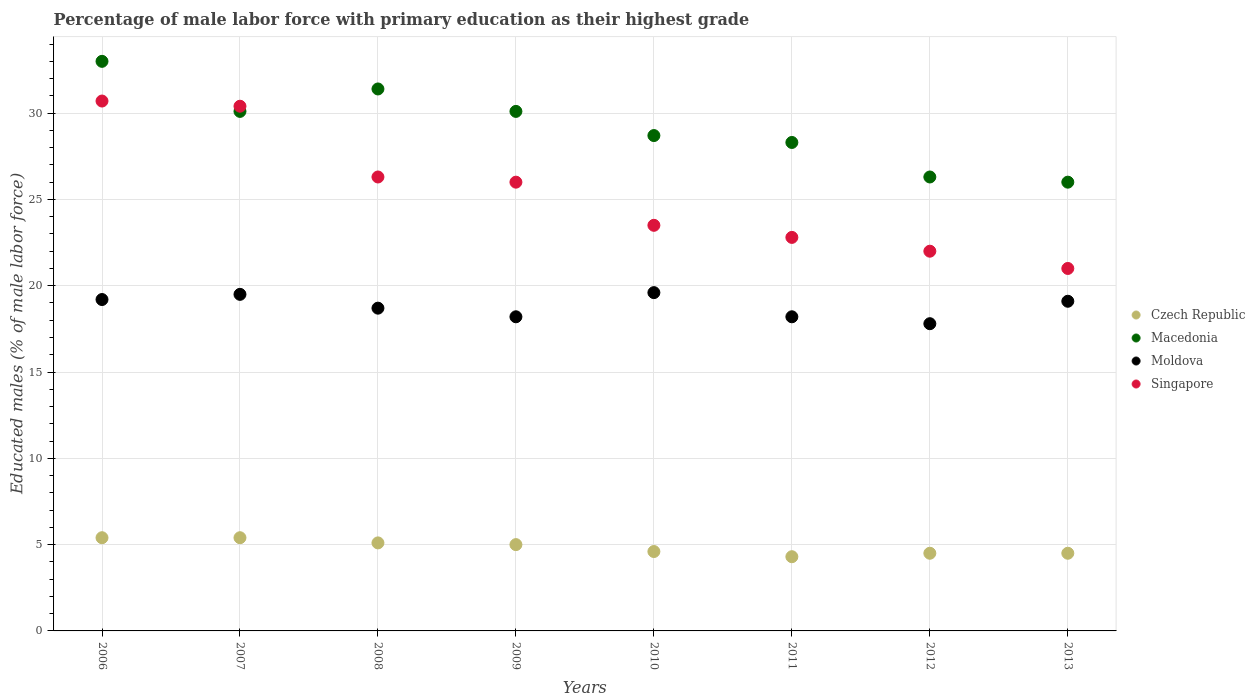Is the number of dotlines equal to the number of legend labels?
Ensure brevity in your answer.  Yes. Across all years, what is the maximum percentage of male labor force with primary education in Singapore?
Provide a succinct answer. 30.7. In which year was the percentage of male labor force with primary education in Singapore maximum?
Your answer should be compact. 2006. What is the total percentage of male labor force with primary education in Singapore in the graph?
Offer a terse response. 202.7. What is the difference between the percentage of male labor force with primary education in Macedonia in 2009 and that in 2013?
Provide a succinct answer. 4.1. What is the difference between the percentage of male labor force with primary education in Macedonia in 2013 and the percentage of male labor force with primary education in Singapore in 2009?
Make the answer very short. 0. What is the average percentage of male labor force with primary education in Singapore per year?
Provide a short and direct response. 25.34. In the year 2007, what is the difference between the percentage of male labor force with primary education in Moldova and percentage of male labor force with primary education in Singapore?
Provide a succinct answer. -10.9. In how many years, is the percentage of male labor force with primary education in Czech Republic greater than 21 %?
Keep it short and to the point. 0. What is the ratio of the percentage of male labor force with primary education in Czech Republic in 2006 to that in 2010?
Your response must be concise. 1.17. Is the percentage of male labor force with primary education in Moldova in 2011 less than that in 2013?
Offer a very short reply. Yes. What is the difference between the highest and the second highest percentage of male labor force with primary education in Singapore?
Give a very brief answer. 0.3. What is the difference between the highest and the lowest percentage of male labor force with primary education in Singapore?
Offer a terse response. 9.7. In how many years, is the percentage of male labor force with primary education in Czech Republic greater than the average percentage of male labor force with primary education in Czech Republic taken over all years?
Offer a very short reply. 4. Does the percentage of male labor force with primary education in Singapore monotonically increase over the years?
Your answer should be very brief. No. Is the percentage of male labor force with primary education in Macedonia strictly less than the percentage of male labor force with primary education in Czech Republic over the years?
Make the answer very short. No. How many years are there in the graph?
Offer a very short reply. 8. What is the difference between two consecutive major ticks on the Y-axis?
Give a very brief answer. 5. Are the values on the major ticks of Y-axis written in scientific E-notation?
Keep it short and to the point. No. What is the title of the graph?
Offer a terse response. Percentage of male labor force with primary education as their highest grade. Does "Mexico" appear as one of the legend labels in the graph?
Offer a terse response. No. What is the label or title of the Y-axis?
Offer a terse response. Educated males (% of male labor force). What is the Educated males (% of male labor force) of Czech Republic in 2006?
Give a very brief answer. 5.4. What is the Educated males (% of male labor force) of Moldova in 2006?
Ensure brevity in your answer.  19.2. What is the Educated males (% of male labor force) in Singapore in 2006?
Make the answer very short. 30.7. What is the Educated males (% of male labor force) of Czech Republic in 2007?
Offer a very short reply. 5.4. What is the Educated males (% of male labor force) in Macedonia in 2007?
Provide a short and direct response. 30.1. What is the Educated males (% of male labor force) in Moldova in 2007?
Offer a very short reply. 19.5. What is the Educated males (% of male labor force) of Singapore in 2007?
Keep it short and to the point. 30.4. What is the Educated males (% of male labor force) of Czech Republic in 2008?
Keep it short and to the point. 5.1. What is the Educated males (% of male labor force) of Macedonia in 2008?
Offer a terse response. 31.4. What is the Educated males (% of male labor force) in Moldova in 2008?
Offer a terse response. 18.7. What is the Educated males (% of male labor force) in Singapore in 2008?
Ensure brevity in your answer.  26.3. What is the Educated males (% of male labor force) in Macedonia in 2009?
Offer a terse response. 30.1. What is the Educated males (% of male labor force) in Moldova in 2009?
Give a very brief answer. 18.2. What is the Educated males (% of male labor force) of Singapore in 2009?
Give a very brief answer. 26. What is the Educated males (% of male labor force) of Czech Republic in 2010?
Keep it short and to the point. 4.6. What is the Educated males (% of male labor force) in Macedonia in 2010?
Your answer should be compact. 28.7. What is the Educated males (% of male labor force) of Moldova in 2010?
Make the answer very short. 19.6. What is the Educated males (% of male labor force) in Czech Republic in 2011?
Offer a terse response. 4.3. What is the Educated males (% of male labor force) in Macedonia in 2011?
Your response must be concise. 28.3. What is the Educated males (% of male labor force) in Moldova in 2011?
Your response must be concise. 18.2. What is the Educated males (% of male labor force) in Singapore in 2011?
Your answer should be very brief. 22.8. What is the Educated males (% of male labor force) of Czech Republic in 2012?
Ensure brevity in your answer.  4.5. What is the Educated males (% of male labor force) in Macedonia in 2012?
Give a very brief answer. 26.3. What is the Educated males (% of male labor force) in Moldova in 2012?
Ensure brevity in your answer.  17.8. What is the Educated males (% of male labor force) of Moldova in 2013?
Provide a succinct answer. 19.1. What is the Educated males (% of male labor force) in Singapore in 2013?
Keep it short and to the point. 21. Across all years, what is the maximum Educated males (% of male labor force) of Czech Republic?
Offer a very short reply. 5.4. Across all years, what is the maximum Educated males (% of male labor force) in Macedonia?
Your response must be concise. 33. Across all years, what is the maximum Educated males (% of male labor force) of Moldova?
Give a very brief answer. 19.6. Across all years, what is the maximum Educated males (% of male labor force) in Singapore?
Provide a short and direct response. 30.7. Across all years, what is the minimum Educated males (% of male labor force) in Czech Republic?
Give a very brief answer. 4.3. Across all years, what is the minimum Educated males (% of male labor force) in Macedonia?
Keep it short and to the point. 26. Across all years, what is the minimum Educated males (% of male labor force) of Moldova?
Make the answer very short. 17.8. Across all years, what is the minimum Educated males (% of male labor force) of Singapore?
Provide a short and direct response. 21. What is the total Educated males (% of male labor force) of Czech Republic in the graph?
Keep it short and to the point. 38.8. What is the total Educated males (% of male labor force) of Macedonia in the graph?
Provide a succinct answer. 233.9. What is the total Educated males (% of male labor force) of Moldova in the graph?
Your answer should be compact. 150.3. What is the total Educated males (% of male labor force) in Singapore in the graph?
Keep it short and to the point. 202.7. What is the difference between the Educated males (% of male labor force) in Macedonia in 2006 and that in 2008?
Provide a succinct answer. 1.6. What is the difference between the Educated males (% of male labor force) in Czech Republic in 2006 and that in 2009?
Give a very brief answer. 0.4. What is the difference between the Educated males (% of male labor force) in Macedonia in 2006 and that in 2009?
Provide a succinct answer. 2.9. What is the difference between the Educated males (% of male labor force) in Czech Republic in 2006 and that in 2010?
Your answer should be compact. 0.8. What is the difference between the Educated males (% of male labor force) of Moldova in 2006 and that in 2010?
Your answer should be compact. -0.4. What is the difference between the Educated males (% of male labor force) in Czech Republic in 2006 and that in 2011?
Your answer should be compact. 1.1. What is the difference between the Educated males (% of male labor force) in Macedonia in 2006 and that in 2011?
Give a very brief answer. 4.7. What is the difference between the Educated males (% of male labor force) in Moldova in 2006 and that in 2011?
Provide a succinct answer. 1. What is the difference between the Educated males (% of male labor force) in Singapore in 2006 and that in 2011?
Your response must be concise. 7.9. What is the difference between the Educated males (% of male labor force) in Czech Republic in 2006 and that in 2012?
Ensure brevity in your answer.  0.9. What is the difference between the Educated males (% of male labor force) of Macedonia in 2006 and that in 2012?
Make the answer very short. 6.7. What is the difference between the Educated males (% of male labor force) in Macedonia in 2007 and that in 2008?
Your response must be concise. -1.3. What is the difference between the Educated males (% of male labor force) in Moldova in 2007 and that in 2008?
Offer a very short reply. 0.8. What is the difference between the Educated males (% of male labor force) of Moldova in 2007 and that in 2009?
Provide a short and direct response. 1.3. What is the difference between the Educated males (% of male labor force) in Czech Republic in 2007 and that in 2010?
Offer a very short reply. 0.8. What is the difference between the Educated males (% of male labor force) of Moldova in 2007 and that in 2010?
Make the answer very short. -0.1. What is the difference between the Educated males (% of male labor force) in Macedonia in 2007 and that in 2011?
Offer a terse response. 1.8. What is the difference between the Educated males (% of male labor force) in Moldova in 2007 and that in 2011?
Provide a short and direct response. 1.3. What is the difference between the Educated males (% of male labor force) in Macedonia in 2007 and that in 2012?
Provide a succinct answer. 3.8. What is the difference between the Educated males (% of male labor force) of Macedonia in 2007 and that in 2013?
Provide a short and direct response. 4.1. What is the difference between the Educated males (% of male labor force) of Moldova in 2007 and that in 2013?
Your answer should be compact. 0.4. What is the difference between the Educated males (% of male labor force) of Singapore in 2007 and that in 2013?
Provide a short and direct response. 9.4. What is the difference between the Educated males (% of male labor force) of Macedonia in 2008 and that in 2009?
Your answer should be very brief. 1.3. What is the difference between the Educated males (% of male labor force) of Macedonia in 2008 and that in 2010?
Provide a succinct answer. 2.7. What is the difference between the Educated males (% of male labor force) of Czech Republic in 2008 and that in 2011?
Provide a succinct answer. 0.8. What is the difference between the Educated males (% of male labor force) of Macedonia in 2008 and that in 2011?
Provide a short and direct response. 3.1. What is the difference between the Educated males (% of male labor force) in Czech Republic in 2008 and that in 2013?
Give a very brief answer. 0.6. What is the difference between the Educated males (% of male labor force) in Moldova in 2008 and that in 2013?
Ensure brevity in your answer.  -0.4. What is the difference between the Educated males (% of male labor force) of Singapore in 2008 and that in 2013?
Provide a succinct answer. 5.3. What is the difference between the Educated males (% of male labor force) in Czech Republic in 2009 and that in 2010?
Keep it short and to the point. 0.4. What is the difference between the Educated males (% of male labor force) in Macedonia in 2009 and that in 2010?
Offer a terse response. 1.4. What is the difference between the Educated males (% of male labor force) in Czech Republic in 2009 and that in 2011?
Provide a short and direct response. 0.7. What is the difference between the Educated males (% of male labor force) in Macedonia in 2009 and that in 2012?
Offer a very short reply. 3.8. What is the difference between the Educated males (% of male labor force) of Macedonia in 2009 and that in 2013?
Give a very brief answer. 4.1. What is the difference between the Educated males (% of male labor force) in Moldova in 2009 and that in 2013?
Provide a succinct answer. -0.9. What is the difference between the Educated males (% of male labor force) in Singapore in 2009 and that in 2013?
Offer a very short reply. 5. What is the difference between the Educated males (% of male labor force) of Macedonia in 2010 and that in 2012?
Make the answer very short. 2.4. What is the difference between the Educated males (% of male labor force) in Czech Republic in 2010 and that in 2013?
Your answer should be compact. 0.1. What is the difference between the Educated males (% of male labor force) in Macedonia in 2010 and that in 2013?
Give a very brief answer. 2.7. What is the difference between the Educated males (% of male labor force) of Moldova in 2011 and that in 2012?
Offer a very short reply. 0.4. What is the difference between the Educated males (% of male labor force) of Singapore in 2011 and that in 2012?
Make the answer very short. 0.8. What is the difference between the Educated males (% of male labor force) of Czech Republic in 2011 and that in 2013?
Provide a short and direct response. -0.2. What is the difference between the Educated males (% of male labor force) of Macedonia in 2011 and that in 2013?
Offer a terse response. 2.3. What is the difference between the Educated males (% of male labor force) of Singapore in 2011 and that in 2013?
Your answer should be very brief. 1.8. What is the difference between the Educated males (% of male labor force) in Czech Republic in 2012 and that in 2013?
Offer a terse response. 0. What is the difference between the Educated males (% of male labor force) in Singapore in 2012 and that in 2013?
Make the answer very short. 1. What is the difference between the Educated males (% of male labor force) in Czech Republic in 2006 and the Educated males (% of male labor force) in Macedonia in 2007?
Make the answer very short. -24.7. What is the difference between the Educated males (% of male labor force) of Czech Republic in 2006 and the Educated males (% of male labor force) of Moldova in 2007?
Keep it short and to the point. -14.1. What is the difference between the Educated males (% of male labor force) of Macedonia in 2006 and the Educated males (% of male labor force) of Singapore in 2007?
Your answer should be very brief. 2.6. What is the difference between the Educated males (% of male labor force) in Moldova in 2006 and the Educated males (% of male labor force) in Singapore in 2007?
Offer a very short reply. -11.2. What is the difference between the Educated males (% of male labor force) of Czech Republic in 2006 and the Educated males (% of male labor force) of Moldova in 2008?
Your answer should be compact. -13.3. What is the difference between the Educated males (% of male labor force) in Czech Republic in 2006 and the Educated males (% of male labor force) in Singapore in 2008?
Give a very brief answer. -20.9. What is the difference between the Educated males (% of male labor force) of Macedonia in 2006 and the Educated males (% of male labor force) of Moldova in 2008?
Offer a very short reply. 14.3. What is the difference between the Educated males (% of male labor force) of Macedonia in 2006 and the Educated males (% of male labor force) of Singapore in 2008?
Offer a very short reply. 6.7. What is the difference between the Educated males (% of male labor force) of Moldova in 2006 and the Educated males (% of male labor force) of Singapore in 2008?
Ensure brevity in your answer.  -7.1. What is the difference between the Educated males (% of male labor force) of Czech Republic in 2006 and the Educated males (% of male labor force) of Macedonia in 2009?
Make the answer very short. -24.7. What is the difference between the Educated males (% of male labor force) in Czech Republic in 2006 and the Educated males (% of male labor force) in Moldova in 2009?
Provide a succinct answer. -12.8. What is the difference between the Educated males (% of male labor force) in Czech Republic in 2006 and the Educated males (% of male labor force) in Singapore in 2009?
Offer a very short reply. -20.6. What is the difference between the Educated males (% of male labor force) in Macedonia in 2006 and the Educated males (% of male labor force) in Moldova in 2009?
Your answer should be compact. 14.8. What is the difference between the Educated males (% of male labor force) in Macedonia in 2006 and the Educated males (% of male labor force) in Singapore in 2009?
Provide a short and direct response. 7. What is the difference between the Educated males (% of male labor force) in Czech Republic in 2006 and the Educated males (% of male labor force) in Macedonia in 2010?
Provide a short and direct response. -23.3. What is the difference between the Educated males (% of male labor force) of Czech Republic in 2006 and the Educated males (% of male labor force) of Moldova in 2010?
Provide a succinct answer. -14.2. What is the difference between the Educated males (% of male labor force) in Czech Republic in 2006 and the Educated males (% of male labor force) in Singapore in 2010?
Keep it short and to the point. -18.1. What is the difference between the Educated males (% of male labor force) in Czech Republic in 2006 and the Educated males (% of male labor force) in Macedonia in 2011?
Provide a succinct answer. -22.9. What is the difference between the Educated males (% of male labor force) in Czech Republic in 2006 and the Educated males (% of male labor force) in Singapore in 2011?
Your answer should be compact. -17.4. What is the difference between the Educated males (% of male labor force) in Czech Republic in 2006 and the Educated males (% of male labor force) in Macedonia in 2012?
Make the answer very short. -20.9. What is the difference between the Educated males (% of male labor force) in Czech Republic in 2006 and the Educated males (% of male labor force) in Singapore in 2012?
Offer a very short reply. -16.6. What is the difference between the Educated males (% of male labor force) in Macedonia in 2006 and the Educated males (% of male labor force) in Moldova in 2012?
Make the answer very short. 15.2. What is the difference between the Educated males (% of male labor force) of Macedonia in 2006 and the Educated males (% of male labor force) of Singapore in 2012?
Ensure brevity in your answer.  11. What is the difference between the Educated males (% of male labor force) of Czech Republic in 2006 and the Educated males (% of male labor force) of Macedonia in 2013?
Ensure brevity in your answer.  -20.6. What is the difference between the Educated males (% of male labor force) in Czech Republic in 2006 and the Educated males (% of male labor force) in Moldova in 2013?
Offer a very short reply. -13.7. What is the difference between the Educated males (% of male labor force) of Czech Republic in 2006 and the Educated males (% of male labor force) of Singapore in 2013?
Offer a very short reply. -15.6. What is the difference between the Educated males (% of male labor force) of Macedonia in 2006 and the Educated males (% of male labor force) of Moldova in 2013?
Ensure brevity in your answer.  13.9. What is the difference between the Educated males (% of male labor force) of Macedonia in 2006 and the Educated males (% of male labor force) of Singapore in 2013?
Your answer should be very brief. 12. What is the difference between the Educated males (% of male labor force) in Czech Republic in 2007 and the Educated males (% of male labor force) in Singapore in 2008?
Your response must be concise. -20.9. What is the difference between the Educated males (% of male labor force) of Czech Republic in 2007 and the Educated males (% of male labor force) of Macedonia in 2009?
Make the answer very short. -24.7. What is the difference between the Educated males (% of male labor force) of Czech Republic in 2007 and the Educated males (% of male labor force) of Moldova in 2009?
Provide a succinct answer. -12.8. What is the difference between the Educated males (% of male labor force) in Czech Republic in 2007 and the Educated males (% of male labor force) in Singapore in 2009?
Offer a very short reply. -20.6. What is the difference between the Educated males (% of male labor force) of Czech Republic in 2007 and the Educated males (% of male labor force) of Macedonia in 2010?
Your response must be concise. -23.3. What is the difference between the Educated males (% of male labor force) of Czech Republic in 2007 and the Educated males (% of male labor force) of Moldova in 2010?
Make the answer very short. -14.2. What is the difference between the Educated males (% of male labor force) of Czech Republic in 2007 and the Educated males (% of male labor force) of Singapore in 2010?
Provide a short and direct response. -18.1. What is the difference between the Educated males (% of male labor force) in Macedonia in 2007 and the Educated males (% of male labor force) in Moldova in 2010?
Your answer should be compact. 10.5. What is the difference between the Educated males (% of male labor force) of Macedonia in 2007 and the Educated males (% of male labor force) of Singapore in 2010?
Give a very brief answer. 6.6. What is the difference between the Educated males (% of male labor force) in Czech Republic in 2007 and the Educated males (% of male labor force) in Macedonia in 2011?
Provide a short and direct response. -22.9. What is the difference between the Educated males (% of male labor force) of Czech Republic in 2007 and the Educated males (% of male labor force) of Moldova in 2011?
Make the answer very short. -12.8. What is the difference between the Educated males (% of male labor force) of Czech Republic in 2007 and the Educated males (% of male labor force) of Singapore in 2011?
Offer a terse response. -17.4. What is the difference between the Educated males (% of male labor force) in Macedonia in 2007 and the Educated males (% of male labor force) in Moldova in 2011?
Provide a short and direct response. 11.9. What is the difference between the Educated males (% of male labor force) of Moldova in 2007 and the Educated males (% of male labor force) of Singapore in 2011?
Keep it short and to the point. -3.3. What is the difference between the Educated males (% of male labor force) of Czech Republic in 2007 and the Educated males (% of male labor force) of Macedonia in 2012?
Make the answer very short. -20.9. What is the difference between the Educated males (% of male labor force) of Czech Republic in 2007 and the Educated males (% of male labor force) of Singapore in 2012?
Keep it short and to the point. -16.6. What is the difference between the Educated males (% of male labor force) in Czech Republic in 2007 and the Educated males (% of male labor force) in Macedonia in 2013?
Ensure brevity in your answer.  -20.6. What is the difference between the Educated males (% of male labor force) in Czech Republic in 2007 and the Educated males (% of male labor force) in Moldova in 2013?
Provide a succinct answer. -13.7. What is the difference between the Educated males (% of male labor force) of Czech Republic in 2007 and the Educated males (% of male labor force) of Singapore in 2013?
Provide a short and direct response. -15.6. What is the difference between the Educated males (% of male labor force) of Moldova in 2007 and the Educated males (% of male labor force) of Singapore in 2013?
Offer a terse response. -1.5. What is the difference between the Educated males (% of male labor force) in Czech Republic in 2008 and the Educated males (% of male labor force) in Singapore in 2009?
Keep it short and to the point. -20.9. What is the difference between the Educated males (% of male labor force) of Moldova in 2008 and the Educated males (% of male labor force) of Singapore in 2009?
Your response must be concise. -7.3. What is the difference between the Educated males (% of male labor force) in Czech Republic in 2008 and the Educated males (% of male labor force) in Macedonia in 2010?
Make the answer very short. -23.6. What is the difference between the Educated males (% of male labor force) in Czech Republic in 2008 and the Educated males (% of male labor force) in Moldova in 2010?
Offer a terse response. -14.5. What is the difference between the Educated males (% of male labor force) in Czech Republic in 2008 and the Educated males (% of male labor force) in Singapore in 2010?
Offer a terse response. -18.4. What is the difference between the Educated males (% of male labor force) in Macedonia in 2008 and the Educated males (% of male labor force) in Singapore in 2010?
Keep it short and to the point. 7.9. What is the difference between the Educated males (% of male labor force) in Czech Republic in 2008 and the Educated males (% of male labor force) in Macedonia in 2011?
Your answer should be compact. -23.2. What is the difference between the Educated males (% of male labor force) of Czech Republic in 2008 and the Educated males (% of male labor force) of Moldova in 2011?
Provide a short and direct response. -13.1. What is the difference between the Educated males (% of male labor force) in Czech Republic in 2008 and the Educated males (% of male labor force) in Singapore in 2011?
Your response must be concise. -17.7. What is the difference between the Educated males (% of male labor force) of Macedonia in 2008 and the Educated males (% of male labor force) of Moldova in 2011?
Offer a very short reply. 13.2. What is the difference between the Educated males (% of male labor force) in Macedonia in 2008 and the Educated males (% of male labor force) in Singapore in 2011?
Keep it short and to the point. 8.6. What is the difference between the Educated males (% of male labor force) in Czech Republic in 2008 and the Educated males (% of male labor force) in Macedonia in 2012?
Provide a short and direct response. -21.2. What is the difference between the Educated males (% of male labor force) in Czech Republic in 2008 and the Educated males (% of male labor force) in Singapore in 2012?
Your response must be concise. -16.9. What is the difference between the Educated males (% of male labor force) of Macedonia in 2008 and the Educated males (% of male labor force) of Moldova in 2012?
Offer a terse response. 13.6. What is the difference between the Educated males (% of male labor force) in Czech Republic in 2008 and the Educated males (% of male labor force) in Macedonia in 2013?
Give a very brief answer. -20.9. What is the difference between the Educated males (% of male labor force) of Czech Republic in 2008 and the Educated males (% of male labor force) of Singapore in 2013?
Keep it short and to the point. -15.9. What is the difference between the Educated males (% of male labor force) of Moldova in 2008 and the Educated males (% of male labor force) of Singapore in 2013?
Provide a short and direct response. -2.3. What is the difference between the Educated males (% of male labor force) of Czech Republic in 2009 and the Educated males (% of male labor force) of Macedonia in 2010?
Offer a very short reply. -23.7. What is the difference between the Educated males (% of male labor force) of Czech Republic in 2009 and the Educated males (% of male labor force) of Moldova in 2010?
Keep it short and to the point. -14.6. What is the difference between the Educated males (% of male labor force) in Czech Republic in 2009 and the Educated males (% of male labor force) in Singapore in 2010?
Your response must be concise. -18.5. What is the difference between the Educated males (% of male labor force) in Macedonia in 2009 and the Educated males (% of male labor force) in Singapore in 2010?
Your response must be concise. 6.6. What is the difference between the Educated males (% of male labor force) of Moldova in 2009 and the Educated males (% of male labor force) of Singapore in 2010?
Provide a succinct answer. -5.3. What is the difference between the Educated males (% of male labor force) of Czech Republic in 2009 and the Educated males (% of male labor force) of Macedonia in 2011?
Offer a terse response. -23.3. What is the difference between the Educated males (% of male labor force) in Czech Republic in 2009 and the Educated males (% of male labor force) in Singapore in 2011?
Your response must be concise. -17.8. What is the difference between the Educated males (% of male labor force) of Macedonia in 2009 and the Educated males (% of male labor force) of Singapore in 2011?
Provide a short and direct response. 7.3. What is the difference between the Educated males (% of male labor force) of Moldova in 2009 and the Educated males (% of male labor force) of Singapore in 2011?
Your answer should be very brief. -4.6. What is the difference between the Educated males (% of male labor force) of Czech Republic in 2009 and the Educated males (% of male labor force) of Macedonia in 2012?
Offer a terse response. -21.3. What is the difference between the Educated males (% of male labor force) in Macedonia in 2009 and the Educated males (% of male labor force) in Singapore in 2012?
Provide a succinct answer. 8.1. What is the difference between the Educated males (% of male labor force) of Moldova in 2009 and the Educated males (% of male labor force) of Singapore in 2012?
Ensure brevity in your answer.  -3.8. What is the difference between the Educated males (% of male labor force) of Czech Republic in 2009 and the Educated males (% of male labor force) of Moldova in 2013?
Your answer should be very brief. -14.1. What is the difference between the Educated males (% of male labor force) in Czech Republic in 2009 and the Educated males (% of male labor force) in Singapore in 2013?
Make the answer very short. -16. What is the difference between the Educated males (% of male labor force) in Macedonia in 2009 and the Educated males (% of male labor force) in Moldova in 2013?
Offer a very short reply. 11. What is the difference between the Educated males (% of male labor force) in Macedonia in 2009 and the Educated males (% of male labor force) in Singapore in 2013?
Your answer should be compact. 9.1. What is the difference between the Educated males (% of male labor force) of Czech Republic in 2010 and the Educated males (% of male labor force) of Macedonia in 2011?
Keep it short and to the point. -23.7. What is the difference between the Educated males (% of male labor force) of Czech Republic in 2010 and the Educated males (% of male labor force) of Singapore in 2011?
Provide a succinct answer. -18.2. What is the difference between the Educated males (% of male labor force) in Macedonia in 2010 and the Educated males (% of male labor force) in Moldova in 2011?
Provide a short and direct response. 10.5. What is the difference between the Educated males (% of male labor force) in Macedonia in 2010 and the Educated males (% of male labor force) in Singapore in 2011?
Your answer should be compact. 5.9. What is the difference between the Educated males (% of male labor force) in Czech Republic in 2010 and the Educated males (% of male labor force) in Macedonia in 2012?
Provide a succinct answer. -21.7. What is the difference between the Educated males (% of male labor force) in Czech Republic in 2010 and the Educated males (% of male labor force) in Moldova in 2012?
Your response must be concise. -13.2. What is the difference between the Educated males (% of male labor force) in Czech Republic in 2010 and the Educated males (% of male labor force) in Singapore in 2012?
Ensure brevity in your answer.  -17.4. What is the difference between the Educated males (% of male labor force) of Moldova in 2010 and the Educated males (% of male labor force) of Singapore in 2012?
Ensure brevity in your answer.  -2.4. What is the difference between the Educated males (% of male labor force) in Czech Republic in 2010 and the Educated males (% of male labor force) in Macedonia in 2013?
Provide a succinct answer. -21.4. What is the difference between the Educated males (% of male labor force) of Czech Republic in 2010 and the Educated males (% of male labor force) of Moldova in 2013?
Offer a very short reply. -14.5. What is the difference between the Educated males (% of male labor force) in Czech Republic in 2010 and the Educated males (% of male labor force) in Singapore in 2013?
Ensure brevity in your answer.  -16.4. What is the difference between the Educated males (% of male labor force) of Moldova in 2010 and the Educated males (% of male labor force) of Singapore in 2013?
Make the answer very short. -1.4. What is the difference between the Educated males (% of male labor force) of Czech Republic in 2011 and the Educated males (% of male labor force) of Macedonia in 2012?
Give a very brief answer. -22. What is the difference between the Educated males (% of male labor force) in Czech Republic in 2011 and the Educated males (% of male labor force) in Moldova in 2012?
Your response must be concise. -13.5. What is the difference between the Educated males (% of male labor force) in Czech Republic in 2011 and the Educated males (% of male labor force) in Singapore in 2012?
Give a very brief answer. -17.7. What is the difference between the Educated males (% of male labor force) of Macedonia in 2011 and the Educated males (% of male labor force) of Moldova in 2012?
Keep it short and to the point. 10.5. What is the difference between the Educated males (% of male labor force) in Macedonia in 2011 and the Educated males (% of male labor force) in Singapore in 2012?
Offer a terse response. 6.3. What is the difference between the Educated males (% of male labor force) of Moldova in 2011 and the Educated males (% of male labor force) of Singapore in 2012?
Offer a terse response. -3.8. What is the difference between the Educated males (% of male labor force) in Czech Republic in 2011 and the Educated males (% of male labor force) in Macedonia in 2013?
Offer a very short reply. -21.7. What is the difference between the Educated males (% of male labor force) of Czech Republic in 2011 and the Educated males (% of male labor force) of Moldova in 2013?
Ensure brevity in your answer.  -14.8. What is the difference between the Educated males (% of male labor force) in Czech Republic in 2011 and the Educated males (% of male labor force) in Singapore in 2013?
Provide a short and direct response. -16.7. What is the difference between the Educated males (% of male labor force) in Macedonia in 2011 and the Educated males (% of male labor force) in Moldova in 2013?
Your response must be concise. 9.2. What is the difference between the Educated males (% of male labor force) in Moldova in 2011 and the Educated males (% of male labor force) in Singapore in 2013?
Offer a terse response. -2.8. What is the difference between the Educated males (% of male labor force) in Czech Republic in 2012 and the Educated males (% of male labor force) in Macedonia in 2013?
Offer a very short reply. -21.5. What is the difference between the Educated males (% of male labor force) of Czech Republic in 2012 and the Educated males (% of male labor force) of Moldova in 2013?
Your answer should be compact. -14.6. What is the difference between the Educated males (% of male labor force) in Czech Republic in 2012 and the Educated males (% of male labor force) in Singapore in 2013?
Keep it short and to the point. -16.5. What is the difference between the Educated males (% of male labor force) of Macedonia in 2012 and the Educated males (% of male labor force) of Singapore in 2013?
Your answer should be compact. 5.3. What is the difference between the Educated males (% of male labor force) of Moldova in 2012 and the Educated males (% of male labor force) of Singapore in 2013?
Keep it short and to the point. -3.2. What is the average Educated males (% of male labor force) of Czech Republic per year?
Provide a succinct answer. 4.85. What is the average Educated males (% of male labor force) in Macedonia per year?
Your answer should be very brief. 29.24. What is the average Educated males (% of male labor force) of Moldova per year?
Your response must be concise. 18.79. What is the average Educated males (% of male labor force) of Singapore per year?
Keep it short and to the point. 25.34. In the year 2006, what is the difference between the Educated males (% of male labor force) in Czech Republic and Educated males (% of male labor force) in Macedonia?
Your answer should be very brief. -27.6. In the year 2006, what is the difference between the Educated males (% of male labor force) in Czech Republic and Educated males (% of male labor force) in Moldova?
Offer a very short reply. -13.8. In the year 2006, what is the difference between the Educated males (% of male labor force) in Czech Republic and Educated males (% of male labor force) in Singapore?
Offer a very short reply. -25.3. In the year 2006, what is the difference between the Educated males (% of male labor force) in Macedonia and Educated males (% of male labor force) in Moldova?
Your answer should be very brief. 13.8. In the year 2006, what is the difference between the Educated males (% of male labor force) of Macedonia and Educated males (% of male labor force) of Singapore?
Provide a short and direct response. 2.3. In the year 2007, what is the difference between the Educated males (% of male labor force) in Czech Republic and Educated males (% of male labor force) in Macedonia?
Ensure brevity in your answer.  -24.7. In the year 2007, what is the difference between the Educated males (% of male labor force) in Czech Republic and Educated males (% of male labor force) in Moldova?
Give a very brief answer. -14.1. In the year 2007, what is the difference between the Educated males (% of male labor force) of Czech Republic and Educated males (% of male labor force) of Singapore?
Provide a succinct answer. -25. In the year 2007, what is the difference between the Educated males (% of male labor force) in Macedonia and Educated males (% of male labor force) in Moldova?
Offer a terse response. 10.6. In the year 2007, what is the difference between the Educated males (% of male labor force) in Moldova and Educated males (% of male labor force) in Singapore?
Give a very brief answer. -10.9. In the year 2008, what is the difference between the Educated males (% of male labor force) in Czech Republic and Educated males (% of male labor force) in Macedonia?
Provide a succinct answer. -26.3. In the year 2008, what is the difference between the Educated males (% of male labor force) in Czech Republic and Educated males (% of male labor force) in Singapore?
Your response must be concise. -21.2. In the year 2008, what is the difference between the Educated males (% of male labor force) of Macedonia and Educated males (% of male labor force) of Singapore?
Ensure brevity in your answer.  5.1. In the year 2008, what is the difference between the Educated males (% of male labor force) of Moldova and Educated males (% of male labor force) of Singapore?
Give a very brief answer. -7.6. In the year 2009, what is the difference between the Educated males (% of male labor force) of Czech Republic and Educated males (% of male labor force) of Macedonia?
Give a very brief answer. -25.1. In the year 2009, what is the difference between the Educated males (% of male labor force) of Czech Republic and Educated males (% of male labor force) of Singapore?
Give a very brief answer. -21. In the year 2009, what is the difference between the Educated males (% of male labor force) of Macedonia and Educated males (% of male labor force) of Singapore?
Keep it short and to the point. 4.1. In the year 2009, what is the difference between the Educated males (% of male labor force) of Moldova and Educated males (% of male labor force) of Singapore?
Make the answer very short. -7.8. In the year 2010, what is the difference between the Educated males (% of male labor force) of Czech Republic and Educated males (% of male labor force) of Macedonia?
Provide a short and direct response. -24.1. In the year 2010, what is the difference between the Educated males (% of male labor force) in Czech Republic and Educated males (% of male labor force) in Moldova?
Offer a terse response. -15. In the year 2010, what is the difference between the Educated males (% of male labor force) of Czech Republic and Educated males (% of male labor force) of Singapore?
Offer a terse response. -18.9. In the year 2010, what is the difference between the Educated males (% of male labor force) in Macedonia and Educated males (% of male labor force) in Singapore?
Provide a succinct answer. 5.2. In the year 2011, what is the difference between the Educated males (% of male labor force) of Czech Republic and Educated males (% of male labor force) of Moldova?
Give a very brief answer. -13.9. In the year 2011, what is the difference between the Educated males (% of male labor force) in Czech Republic and Educated males (% of male labor force) in Singapore?
Make the answer very short. -18.5. In the year 2011, what is the difference between the Educated males (% of male labor force) of Macedonia and Educated males (% of male labor force) of Moldova?
Offer a very short reply. 10.1. In the year 2012, what is the difference between the Educated males (% of male labor force) of Czech Republic and Educated males (% of male labor force) of Macedonia?
Ensure brevity in your answer.  -21.8. In the year 2012, what is the difference between the Educated males (% of male labor force) in Czech Republic and Educated males (% of male labor force) in Moldova?
Make the answer very short. -13.3. In the year 2012, what is the difference between the Educated males (% of male labor force) in Czech Republic and Educated males (% of male labor force) in Singapore?
Give a very brief answer. -17.5. In the year 2012, what is the difference between the Educated males (% of male labor force) of Macedonia and Educated males (% of male labor force) of Moldova?
Your answer should be compact. 8.5. In the year 2012, what is the difference between the Educated males (% of male labor force) in Moldova and Educated males (% of male labor force) in Singapore?
Provide a succinct answer. -4.2. In the year 2013, what is the difference between the Educated males (% of male labor force) in Czech Republic and Educated males (% of male labor force) in Macedonia?
Provide a succinct answer. -21.5. In the year 2013, what is the difference between the Educated males (% of male labor force) of Czech Republic and Educated males (% of male labor force) of Moldova?
Provide a short and direct response. -14.6. In the year 2013, what is the difference between the Educated males (% of male labor force) in Czech Republic and Educated males (% of male labor force) in Singapore?
Make the answer very short. -16.5. In the year 2013, what is the difference between the Educated males (% of male labor force) of Macedonia and Educated males (% of male labor force) of Moldova?
Ensure brevity in your answer.  6.9. In the year 2013, what is the difference between the Educated males (% of male labor force) in Moldova and Educated males (% of male labor force) in Singapore?
Offer a terse response. -1.9. What is the ratio of the Educated males (% of male labor force) in Macedonia in 2006 to that in 2007?
Ensure brevity in your answer.  1.1. What is the ratio of the Educated males (% of male labor force) of Moldova in 2006 to that in 2007?
Offer a very short reply. 0.98. What is the ratio of the Educated males (% of male labor force) of Singapore in 2006 to that in 2007?
Ensure brevity in your answer.  1.01. What is the ratio of the Educated males (% of male labor force) in Czech Republic in 2006 to that in 2008?
Your answer should be compact. 1.06. What is the ratio of the Educated males (% of male labor force) in Macedonia in 2006 to that in 2008?
Keep it short and to the point. 1.05. What is the ratio of the Educated males (% of male labor force) in Moldova in 2006 to that in 2008?
Ensure brevity in your answer.  1.03. What is the ratio of the Educated males (% of male labor force) in Singapore in 2006 to that in 2008?
Your answer should be compact. 1.17. What is the ratio of the Educated males (% of male labor force) in Macedonia in 2006 to that in 2009?
Give a very brief answer. 1.1. What is the ratio of the Educated males (% of male labor force) in Moldova in 2006 to that in 2009?
Provide a short and direct response. 1.05. What is the ratio of the Educated males (% of male labor force) of Singapore in 2006 to that in 2009?
Ensure brevity in your answer.  1.18. What is the ratio of the Educated males (% of male labor force) in Czech Republic in 2006 to that in 2010?
Keep it short and to the point. 1.17. What is the ratio of the Educated males (% of male labor force) in Macedonia in 2006 to that in 2010?
Offer a very short reply. 1.15. What is the ratio of the Educated males (% of male labor force) of Moldova in 2006 to that in 2010?
Make the answer very short. 0.98. What is the ratio of the Educated males (% of male labor force) of Singapore in 2006 to that in 2010?
Provide a succinct answer. 1.31. What is the ratio of the Educated males (% of male labor force) of Czech Republic in 2006 to that in 2011?
Offer a terse response. 1.26. What is the ratio of the Educated males (% of male labor force) of Macedonia in 2006 to that in 2011?
Provide a short and direct response. 1.17. What is the ratio of the Educated males (% of male labor force) in Moldova in 2006 to that in 2011?
Provide a succinct answer. 1.05. What is the ratio of the Educated males (% of male labor force) in Singapore in 2006 to that in 2011?
Provide a succinct answer. 1.35. What is the ratio of the Educated males (% of male labor force) in Macedonia in 2006 to that in 2012?
Your answer should be very brief. 1.25. What is the ratio of the Educated males (% of male labor force) in Moldova in 2006 to that in 2012?
Keep it short and to the point. 1.08. What is the ratio of the Educated males (% of male labor force) of Singapore in 2006 to that in 2012?
Keep it short and to the point. 1.4. What is the ratio of the Educated males (% of male labor force) in Czech Republic in 2006 to that in 2013?
Offer a terse response. 1.2. What is the ratio of the Educated males (% of male labor force) of Macedonia in 2006 to that in 2013?
Your answer should be compact. 1.27. What is the ratio of the Educated males (% of male labor force) of Singapore in 2006 to that in 2013?
Offer a very short reply. 1.46. What is the ratio of the Educated males (% of male labor force) in Czech Republic in 2007 to that in 2008?
Keep it short and to the point. 1.06. What is the ratio of the Educated males (% of male labor force) of Macedonia in 2007 to that in 2008?
Provide a short and direct response. 0.96. What is the ratio of the Educated males (% of male labor force) in Moldova in 2007 to that in 2008?
Your answer should be very brief. 1.04. What is the ratio of the Educated males (% of male labor force) in Singapore in 2007 to that in 2008?
Ensure brevity in your answer.  1.16. What is the ratio of the Educated males (% of male labor force) in Moldova in 2007 to that in 2009?
Provide a short and direct response. 1.07. What is the ratio of the Educated males (% of male labor force) in Singapore in 2007 to that in 2009?
Provide a succinct answer. 1.17. What is the ratio of the Educated males (% of male labor force) in Czech Republic in 2007 to that in 2010?
Ensure brevity in your answer.  1.17. What is the ratio of the Educated males (% of male labor force) in Macedonia in 2007 to that in 2010?
Your answer should be very brief. 1.05. What is the ratio of the Educated males (% of male labor force) of Moldova in 2007 to that in 2010?
Your answer should be compact. 0.99. What is the ratio of the Educated males (% of male labor force) in Singapore in 2007 to that in 2010?
Ensure brevity in your answer.  1.29. What is the ratio of the Educated males (% of male labor force) of Czech Republic in 2007 to that in 2011?
Make the answer very short. 1.26. What is the ratio of the Educated males (% of male labor force) of Macedonia in 2007 to that in 2011?
Your response must be concise. 1.06. What is the ratio of the Educated males (% of male labor force) in Moldova in 2007 to that in 2011?
Make the answer very short. 1.07. What is the ratio of the Educated males (% of male labor force) in Macedonia in 2007 to that in 2012?
Provide a short and direct response. 1.14. What is the ratio of the Educated males (% of male labor force) of Moldova in 2007 to that in 2012?
Your answer should be compact. 1.1. What is the ratio of the Educated males (% of male labor force) in Singapore in 2007 to that in 2012?
Make the answer very short. 1.38. What is the ratio of the Educated males (% of male labor force) of Czech Republic in 2007 to that in 2013?
Ensure brevity in your answer.  1.2. What is the ratio of the Educated males (% of male labor force) in Macedonia in 2007 to that in 2013?
Offer a very short reply. 1.16. What is the ratio of the Educated males (% of male labor force) in Moldova in 2007 to that in 2013?
Offer a terse response. 1.02. What is the ratio of the Educated males (% of male labor force) of Singapore in 2007 to that in 2013?
Give a very brief answer. 1.45. What is the ratio of the Educated males (% of male labor force) of Czech Republic in 2008 to that in 2009?
Ensure brevity in your answer.  1.02. What is the ratio of the Educated males (% of male labor force) in Macedonia in 2008 to that in 2009?
Your response must be concise. 1.04. What is the ratio of the Educated males (% of male labor force) in Moldova in 2008 to that in 2009?
Offer a terse response. 1.03. What is the ratio of the Educated males (% of male labor force) of Singapore in 2008 to that in 2009?
Give a very brief answer. 1.01. What is the ratio of the Educated males (% of male labor force) of Czech Republic in 2008 to that in 2010?
Make the answer very short. 1.11. What is the ratio of the Educated males (% of male labor force) of Macedonia in 2008 to that in 2010?
Ensure brevity in your answer.  1.09. What is the ratio of the Educated males (% of male labor force) of Moldova in 2008 to that in 2010?
Provide a succinct answer. 0.95. What is the ratio of the Educated males (% of male labor force) in Singapore in 2008 to that in 2010?
Keep it short and to the point. 1.12. What is the ratio of the Educated males (% of male labor force) in Czech Republic in 2008 to that in 2011?
Keep it short and to the point. 1.19. What is the ratio of the Educated males (% of male labor force) of Macedonia in 2008 to that in 2011?
Provide a succinct answer. 1.11. What is the ratio of the Educated males (% of male labor force) in Moldova in 2008 to that in 2011?
Offer a very short reply. 1.03. What is the ratio of the Educated males (% of male labor force) of Singapore in 2008 to that in 2011?
Your answer should be compact. 1.15. What is the ratio of the Educated males (% of male labor force) of Czech Republic in 2008 to that in 2012?
Provide a succinct answer. 1.13. What is the ratio of the Educated males (% of male labor force) of Macedonia in 2008 to that in 2012?
Provide a short and direct response. 1.19. What is the ratio of the Educated males (% of male labor force) in Moldova in 2008 to that in 2012?
Ensure brevity in your answer.  1.05. What is the ratio of the Educated males (% of male labor force) of Singapore in 2008 to that in 2012?
Your answer should be very brief. 1.2. What is the ratio of the Educated males (% of male labor force) in Czech Republic in 2008 to that in 2013?
Ensure brevity in your answer.  1.13. What is the ratio of the Educated males (% of male labor force) in Macedonia in 2008 to that in 2013?
Make the answer very short. 1.21. What is the ratio of the Educated males (% of male labor force) of Moldova in 2008 to that in 2013?
Give a very brief answer. 0.98. What is the ratio of the Educated males (% of male labor force) of Singapore in 2008 to that in 2013?
Give a very brief answer. 1.25. What is the ratio of the Educated males (% of male labor force) of Czech Republic in 2009 to that in 2010?
Give a very brief answer. 1.09. What is the ratio of the Educated males (% of male labor force) in Macedonia in 2009 to that in 2010?
Your answer should be compact. 1.05. What is the ratio of the Educated males (% of male labor force) in Singapore in 2009 to that in 2010?
Offer a terse response. 1.11. What is the ratio of the Educated males (% of male labor force) of Czech Republic in 2009 to that in 2011?
Provide a short and direct response. 1.16. What is the ratio of the Educated males (% of male labor force) in Macedonia in 2009 to that in 2011?
Provide a short and direct response. 1.06. What is the ratio of the Educated males (% of male labor force) in Moldova in 2009 to that in 2011?
Provide a short and direct response. 1. What is the ratio of the Educated males (% of male labor force) of Singapore in 2009 to that in 2011?
Offer a terse response. 1.14. What is the ratio of the Educated males (% of male labor force) of Czech Republic in 2009 to that in 2012?
Provide a succinct answer. 1.11. What is the ratio of the Educated males (% of male labor force) in Macedonia in 2009 to that in 2012?
Give a very brief answer. 1.14. What is the ratio of the Educated males (% of male labor force) in Moldova in 2009 to that in 2012?
Your answer should be compact. 1.02. What is the ratio of the Educated males (% of male labor force) of Singapore in 2009 to that in 2012?
Offer a very short reply. 1.18. What is the ratio of the Educated males (% of male labor force) of Czech Republic in 2009 to that in 2013?
Ensure brevity in your answer.  1.11. What is the ratio of the Educated males (% of male labor force) in Macedonia in 2009 to that in 2013?
Provide a succinct answer. 1.16. What is the ratio of the Educated males (% of male labor force) in Moldova in 2009 to that in 2013?
Your answer should be very brief. 0.95. What is the ratio of the Educated males (% of male labor force) in Singapore in 2009 to that in 2013?
Your response must be concise. 1.24. What is the ratio of the Educated males (% of male labor force) of Czech Republic in 2010 to that in 2011?
Provide a short and direct response. 1.07. What is the ratio of the Educated males (% of male labor force) of Macedonia in 2010 to that in 2011?
Your answer should be compact. 1.01. What is the ratio of the Educated males (% of male labor force) of Moldova in 2010 to that in 2011?
Keep it short and to the point. 1.08. What is the ratio of the Educated males (% of male labor force) of Singapore in 2010 to that in 2011?
Keep it short and to the point. 1.03. What is the ratio of the Educated males (% of male labor force) in Czech Republic in 2010 to that in 2012?
Keep it short and to the point. 1.02. What is the ratio of the Educated males (% of male labor force) in Macedonia in 2010 to that in 2012?
Ensure brevity in your answer.  1.09. What is the ratio of the Educated males (% of male labor force) in Moldova in 2010 to that in 2012?
Provide a succinct answer. 1.1. What is the ratio of the Educated males (% of male labor force) in Singapore in 2010 to that in 2012?
Keep it short and to the point. 1.07. What is the ratio of the Educated males (% of male labor force) in Czech Republic in 2010 to that in 2013?
Ensure brevity in your answer.  1.02. What is the ratio of the Educated males (% of male labor force) in Macedonia in 2010 to that in 2013?
Offer a terse response. 1.1. What is the ratio of the Educated males (% of male labor force) in Moldova in 2010 to that in 2013?
Your answer should be compact. 1.03. What is the ratio of the Educated males (% of male labor force) in Singapore in 2010 to that in 2013?
Make the answer very short. 1.12. What is the ratio of the Educated males (% of male labor force) in Czech Republic in 2011 to that in 2012?
Your answer should be very brief. 0.96. What is the ratio of the Educated males (% of male labor force) in Macedonia in 2011 to that in 2012?
Ensure brevity in your answer.  1.08. What is the ratio of the Educated males (% of male labor force) of Moldova in 2011 to that in 2012?
Ensure brevity in your answer.  1.02. What is the ratio of the Educated males (% of male labor force) of Singapore in 2011 to that in 2012?
Offer a terse response. 1.04. What is the ratio of the Educated males (% of male labor force) in Czech Republic in 2011 to that in 2013?
Offer a terse response. 0.96. What is the ratio of the Educated males (% of male labor force) in Macedonia in 2011 to that in 2013?
Your answer should be very brief. 1.09. What is the ratio of the Educated males (% of male labor force) of Moldova in 2011 to that in 2013?
Give a very brief answer. 0.95. What is the ratio of the Educated males (% of male labor force) in Singapore in 2011 to that in 2013?
Offer a terse response. 1.09. What is the ratio of the Educated males (% of male labor force) of Czech Republic in 2012 to that in 2013?
Ensure brevity in your answer.  1. What is the ratio of the Educated males (% of male labor force) in Macedonia in 2012 to that in 2013?
Ensure brevity in your answer.  1.01. What is the ratio of the Educated males (% of male labor force) of Moldova in 2012 to that in 2013?
Keep it short and to the point. 0.93. What is the ratio of the Educated males (% of male labor force) in Singapore in 2012 to that in 2013?
Your answer should be compact. 1.05. What is the difference between the highest and the second highest Educated males (% of male labor force) of Macedonia?
Your answer should be compact. 1.6. What is the difference between the highest and the second highest Educated males (% of male labor force) of Singapore?
Keep it short and to the point. 0.3. What is the difference between the highest and the lowest Educated males (% of male labor force) in Macedonia?
Keep it short and to the point. 7. What is the difference between the highest and the lowest Educated males (% of male labor force) in Singapore?
Provide a succinct answer. 9.7. 